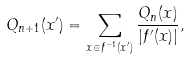<formula> <loc_0><loc_0><loc_500><loc_500>Q _ { n + 1 } ( x ^ { \prime } ) = \sum _ { x \in f ^ { - 1 } ( x ^ { \prime } ) } \frac { Q _ { n } ( x ) } { | f ^ { \prime } ( x ) | } ,</formula> 